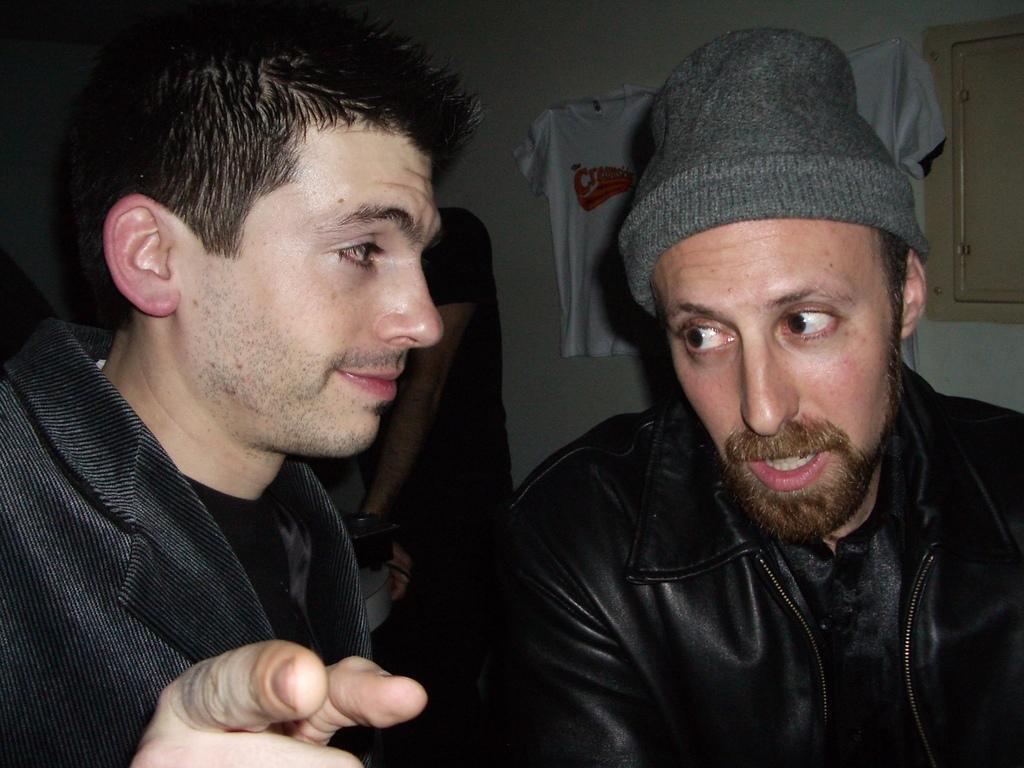How many people are in the image? There are people in the image, but the exact number is not specified. What is one person wearing in the image? One person is wearing a cap in the image. What can be seen in the background of the image? There is a wall in the background of the image. What type of clothing is near the wall? There is a t-shirt near the wall in the image. What architectural feature is on the right side of the image? There is a door on the right side of the image. Is there a cobweb visible on the door in the image? There is no mention of a cobweb in the image, so it cannot be determined from the facts provided. 